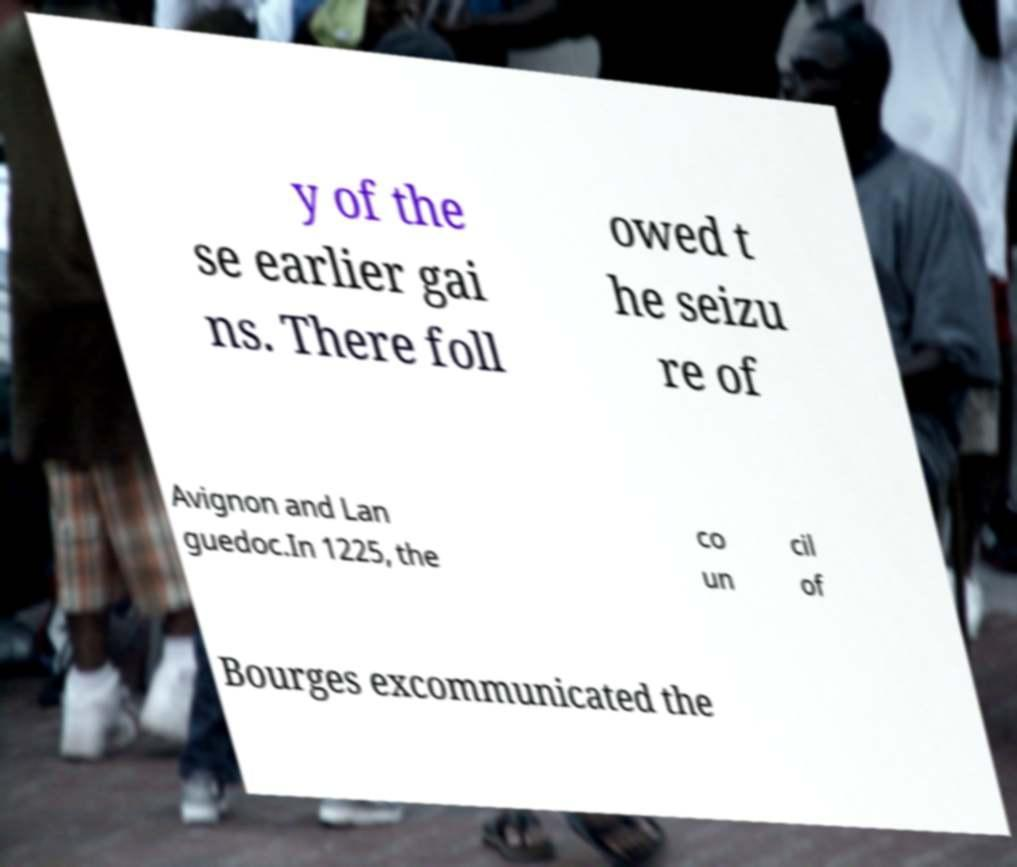Please read and relay the text visible in this image. What does it say? y of the se earlier gai ns. There foll owed t he seizu re of Avignon and Lan guedoc.In 1225, the co un cil of Bourges excommunicated the 